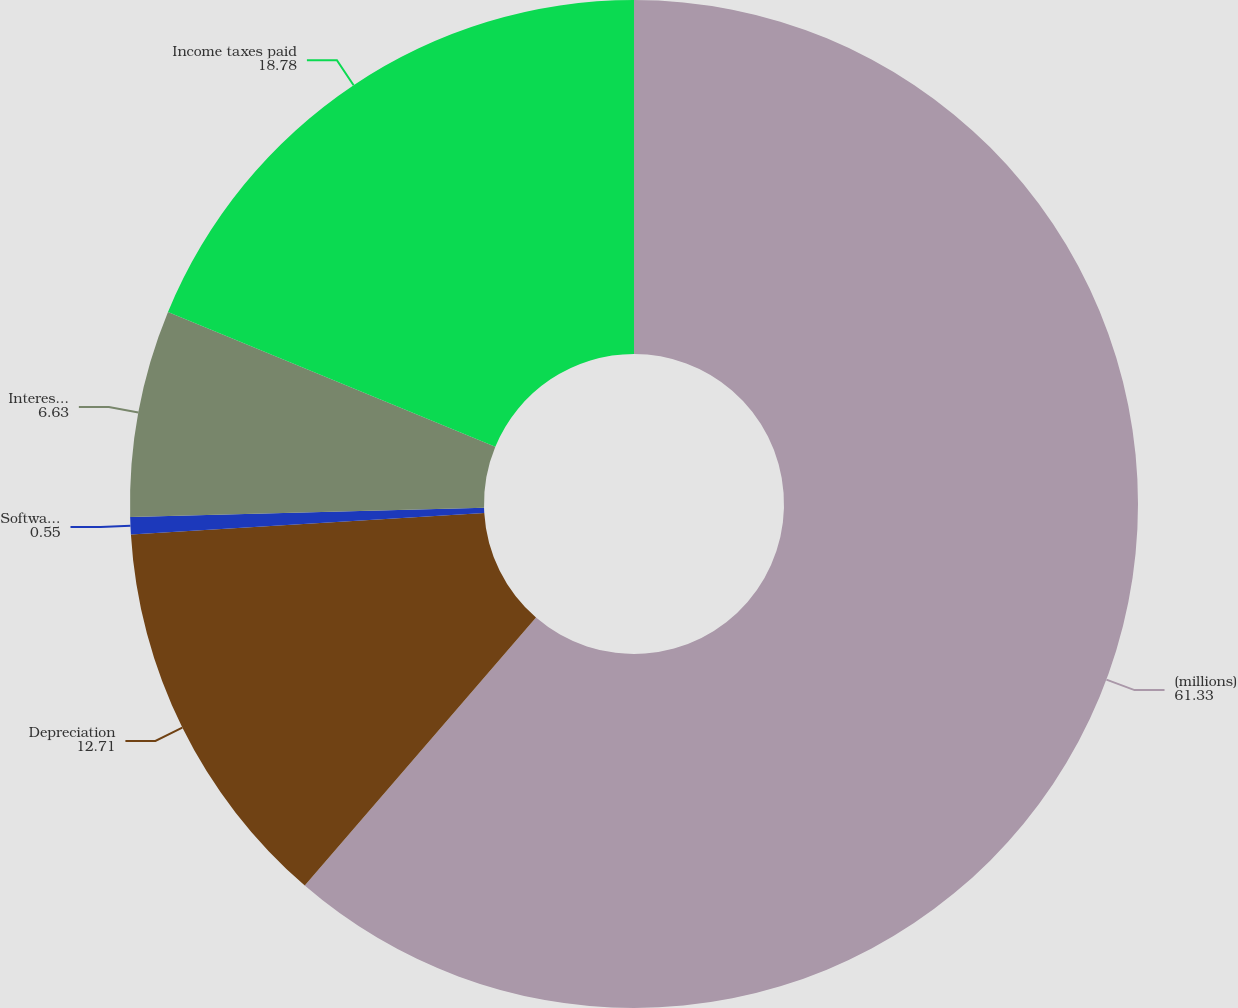<chart> <loc_0><loc_0><loc_500><loc_500><pie_chart><fcel>(millions)<fcel>Depreciation<fcel>Software amortization<fcel>Interest paid<fcel>Income taxes paid<nl><fcel>61.33%<fcel>12.71%<fcel>0.55%<fcel>6.63%<fcel>18.78%<nl></chart> 